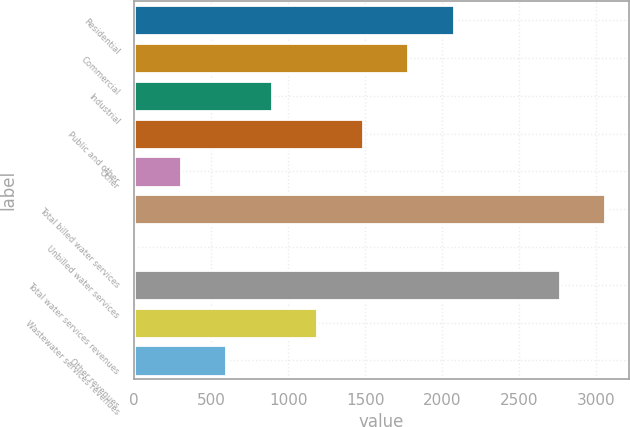Convert chart. <chart><loc_0><loc_0><loc_500><loc_500><bar_chart><fcel>Residential<fcel>Commercial<fcel>Industrial<fcel>Public and other<fcel>Other<fcel>Total billed water services<fcel>Unbilled water services<fcel>Total water services revenues<fcel>Wastewater services revenues<fcel>Other revenues<nl><fcel>2073.9<fcel>1779.2<fcel>895.1<fcel>1484.5<fcel>305.7<fcel>3059.7<fcel>11<fcel>2765<fcel>1189.8<fcel>600.4<nl></chart> 